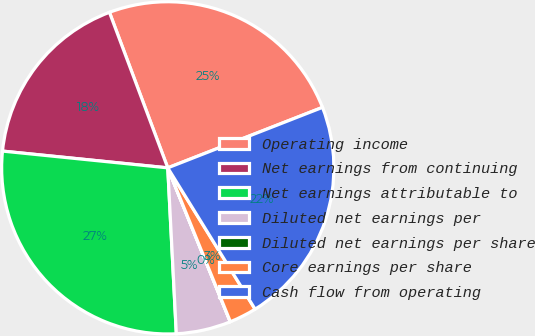<chart> <loc_0><loc_0><loc_500><loc_500><pie_chart><fcel>Operating income<fcel>Net earnings from continuing<fcel>Net earnings attributable to<fcel>Diluted net earnings per<fcel>Diluted net earnings per share<fcel>Core earnings per share<fcel>Cash flow from operating<nl><fcel>24.78%<fcel>17.68%<fcel>27.43%<fcel>5.32%<fcel>0.01%<fcel>2.66%<fcel>22.12%<nl></chart> 